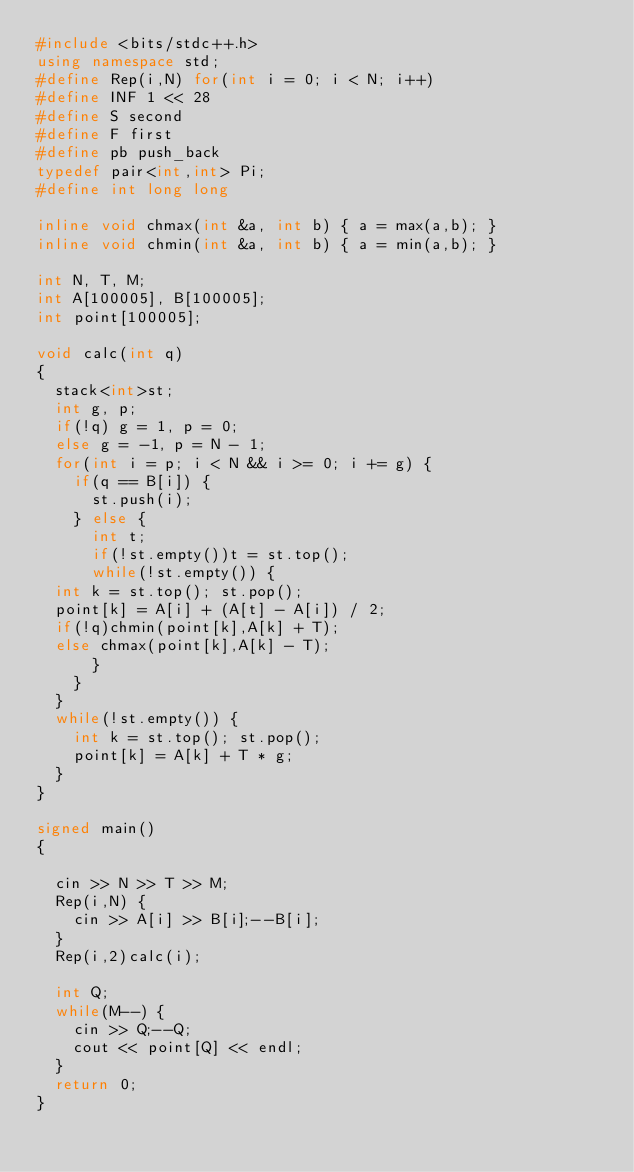Convert code to text. <code><loc_0><loc_0><loc_500><loc_500><_C++_>#include <bits/stdc++.h>
using namespace std;
#define Rep(i,N) for(int i = 0; i < N; i++)
#define INF 1 << 28
#define S second
#define F first
#define pb push_back
typedef pair<int,int> Pi;
#define int long long

inline void chmax(int &a, int b) { a = max(a,b); }
inline void chmin(int &a, int b) { a = min(a,b); }

int N, T, M;
int A[100005], B[100005];
int point[100005];

void calc(int q)
{
  stack<int>st;
  int g, p;
  if(!q) g = 1, p = 0;
  else g = -1, p = N - 1;
  for(int i = p; i < N && i >= 0; i += g) {
    if(q == B[i]) {
      st.push(i);
    } else {
      int t;
      if(!st.empty())t = st.top();
      while(!st.empty()) {
	int k = st.top(); st.pop();
	point[k] = A[i] + (A[t] - A[i]) / 2;
	if(!q)chmin(point[k],A[k] + T);
	else chmax(point[k],A[k] - T);
      }
    }
  }
  while(!st.empty()) {
    int k = st.top(); st.pop();
    point[k] = A[k] + T * g;
  }
} 

signed main()
{
  
  cin >> N >> T >> M;
  Rep(i,N) {
    cin >> A[i] >> B[i];--B[i];
  }
  Rep(i,2)calc(i);
  
  int Q;
  while(M--) {
    cin >> Q;--Q;
    cout << point[Q] << endl;
  }
  return 0;
}</code> 